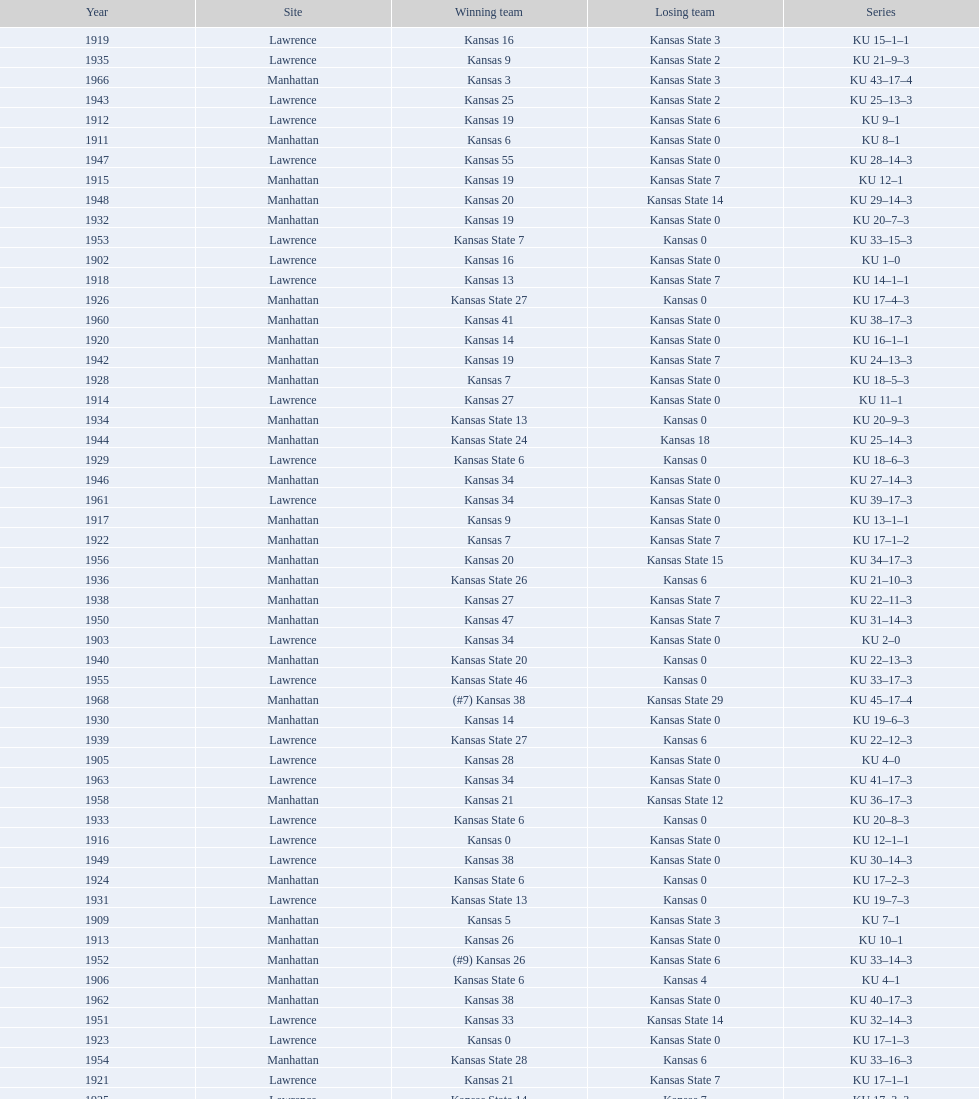What is the total number of games played? 66. 